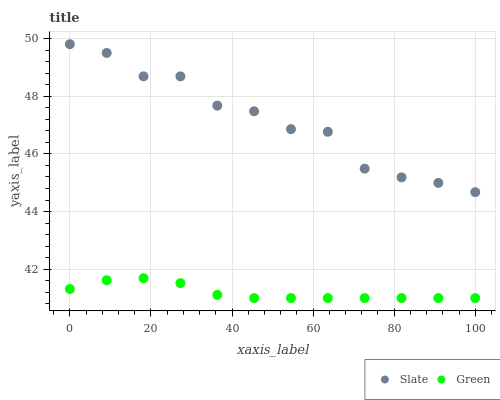Does Green have the minimum area under the curve?
Answer yes or no. Yes. Does Slate have the maximum area under the curve?
Answer yes or no. Yes. Does Green have the maximum area under the curve?
Answer yes or no. No. Is Green the smoothest?
Answer yes or no. Yes. Is Slate the roughest?
Answer yes or no. Yes. Is Green the roughest?
Answer yes or no. No. Does Green have the lowest value?
Answer yes or no. Yes. Does Slate have the highest value?
Answer yes or no. Yes. Does Green have the highest value?
Answer yes or no. No. Is Green less than Slate?
Answer yes or no. Yes. Is Slate greater than Green?
Answer yes or no. Yes. Does Green intersect Slate?
Answer yes or no. No. 